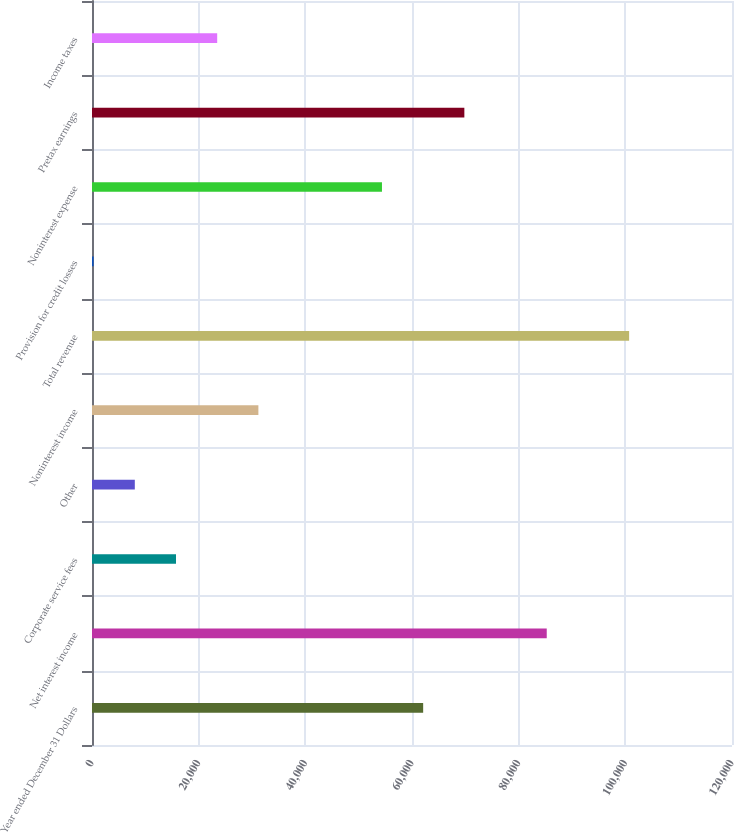Convert chart to OTSL. <chart><loc_0><loc_0><loc_500><loc_500><bar_chart><fcel>Year ended December 31 Dollars<fcel>Net interest income<fcel>Corporate service fees<fcel>Other<fcel>Noninterest income<fcel>Total revenue<fcel>Provision for credit losses<fcel>Noninterest expense<fcel>Pretax earnings<fcel>Income taxes<nl><fcel>62092.6<fcel>85263.7<fcel>15750.4<fcel>8026.7<fcel>31197.8<fcel>100711<fcel>303<fcel>54368.9<fcel>69816.3<fcel>23474.1<nl></chart> 